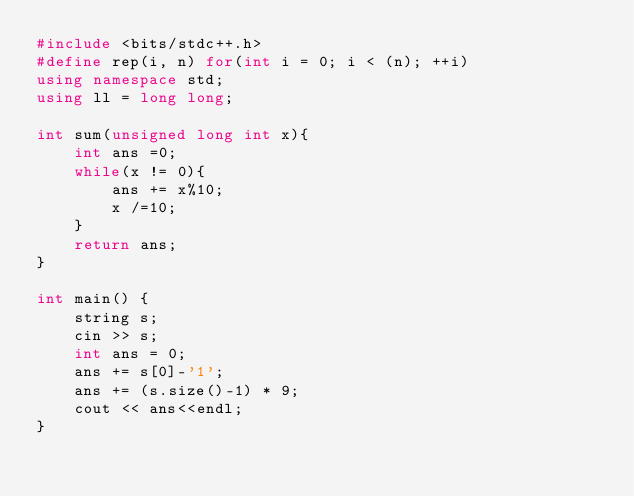Convert code to text. <code><loc_0><loc_0><loc_500><loc_500><_C++_>#include <bits/stdc++.h>
#define rep(i, n) for(int i = 0; i < (n); ++i)
using namespace std;
using ll = long long;

int sum(unsigned long int x){
    int ans =0;
    while(x != 0){
        ans += x%10;
        x /=10;
    }
    return ans;
}

int main() { 
    string s;
    cin >> s;
    int ans = 0;
    ans += s[0]-'1';
    ans += (s.size()-1) * 9;
    cout << ans<<endl;
}</code> 